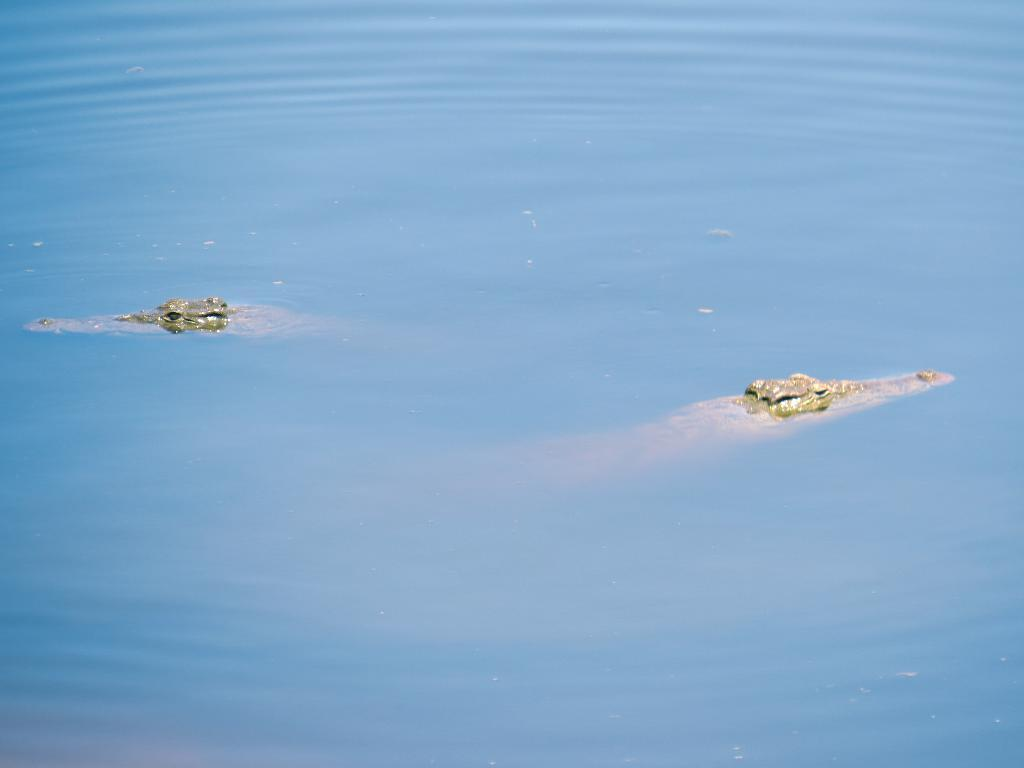How many crocodiles are present in the image? There are two crocodiles in the image. Where are the crocodiles located in the image? The crocodiles are in the water. What type of coal is being used to build a bridge in the image? There is no coal or bridge present in the image; it features two crocodiles in the water. 